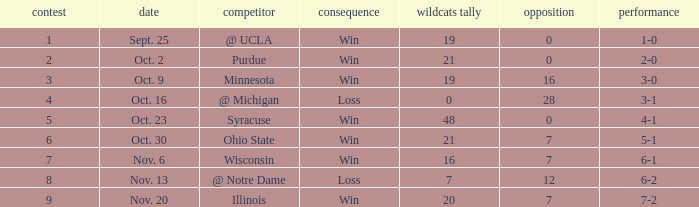What game number did the Wildcats play Purdue? 2.0. 